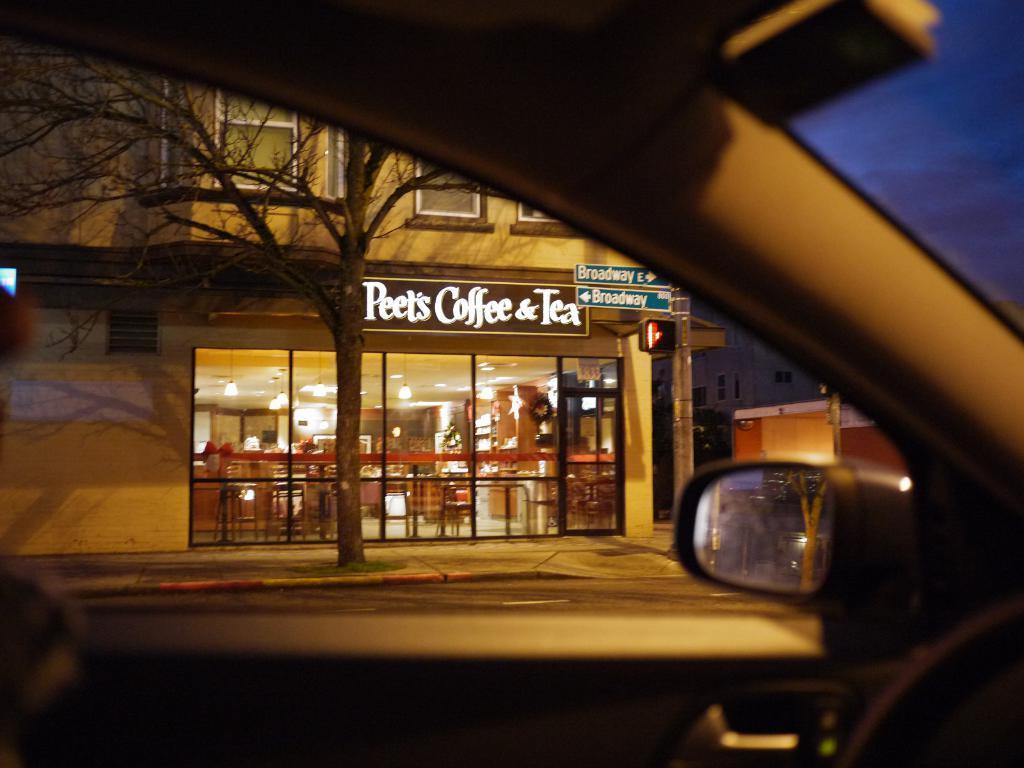Can you describe this image briefly? In this picture we can see a car, in the background we can find few buildings, lights, sign boards and a tree, in the middle of the image we can see a hoarding, we can find some text on the sign boards and hoarding. 